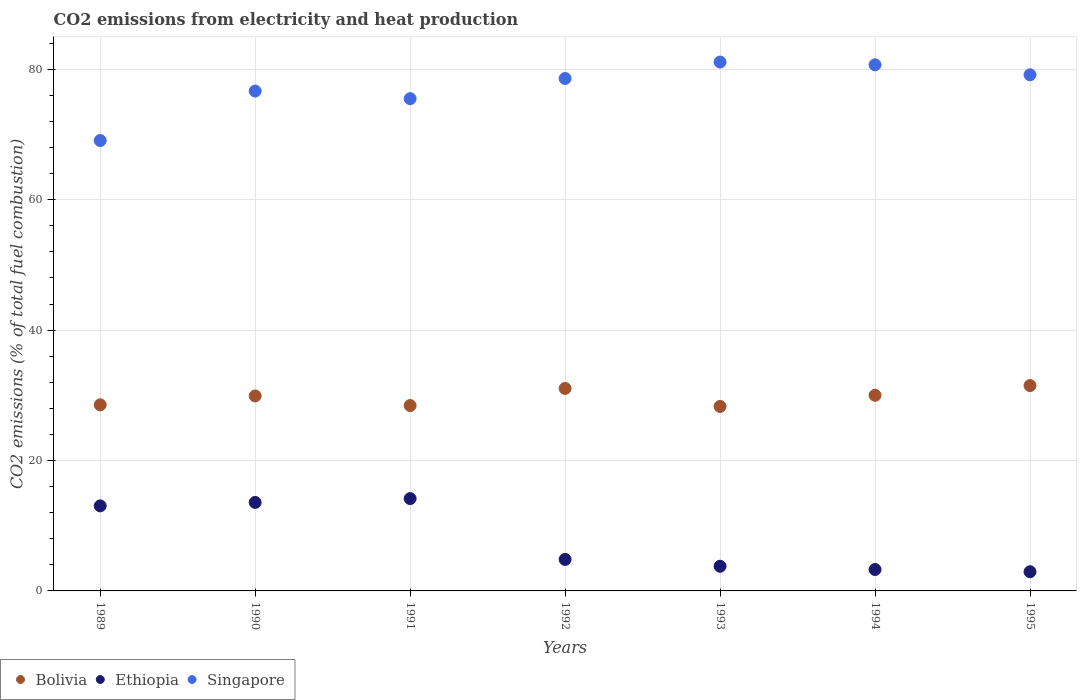How many different coloured dotlines are there?
Keep it short and to the point. 3. Is the number of dotlines equal to the number of legend labels?
Your answer should be very brief. Yes. What is the amount of CO2 emitted in Ethiopia in 1995?
Your answer should be very brief. 2.94. Across all years, what is the maximum amount of CO2 emitted in Ethiopia?
Your answer should be compact. 14.16. Across all years, what is the minimum amount of CO2 emitted in Bolivia?
Your response must be concise. 28.29. In which year was the amount of CO2 emitted in Singapore maximum?
Make the answer very short. 1993. In which year was the amount of CO2 emitted in Ethiopia minimum?
Give a very brief answer. 1995. What is the total amount of CO2 emitted in Bolivia in the graph?
Give a very brief answer. 207.72. What is the difference between the amount of CO2 emitted in Ethiopia in 1990 and that in 1993?
Provide a short and direct response. 9.79. What is the difference between the amount of CO2 emitted in Ethiopia in 1993 and the amount of CO2 emitted in Bolivia in 1992?
Provide a succinct answer. -27.27. What is the average amount of CO2 emitted in Singapore per year?
Offer a terse response. 77.25. In the year 1989, what is the difference between the amount of CO2 emitted in Bolivia and amount of CO2 emitted in Singapore?
Make the answer very short. -40.53. In how many years, is the amount of CO2 emitted in Bolivia greater than 52 %?
Offer a very short reply. 0. What is the ratio of the amount of CO2 emitted in Ethiopia in 1993 to that in 1995?
Offer a very short reply. 1.29. Is the difference between the amount of CO2 emitted in Bolivia in 1992 and 1993 greater than the difference between the amount of CO2 emitted in Singapore in 1992 and 1993?
Ensure brevity in your answer.  Yes. What is the difference between the highest and the second highest amount of CO2 emitted in Ethiopia?
Ensure brevity in your answer.  0.58. What is the difference between the highest and the lowest amount of CO2 emitted in Singapore?
Offer a terse response. 12.03. Is it the case that in every year, the sum of the amount of CO2 emitted in Ethiopia and amount of CO2 emitted in Singapore  is greater than the amount of CO2 emitted in Bolivia?
Offer a terse response. Yes. Does the amount of CO2 emitted in Ethiopia monotonically increase over the years?
Provide a succinct answer. No. Is the amount of CO2 emitted in Bolivia strictly greater than the amount of CO2 emitted in Singapore over the years?
Keep it short and to the point. No. Is the amount of CO2 emitted in Ethiopia strictly less than the amount of CO2 emitted in Bolivia over the years?
Provide a short and direct response. Yes. How many years are there in the graph?
Keep it short and to the point. 7. Does the graph contain grids?
Provide a succinct answer. Yes. How are the legend labels stacked?
Make the answer very short. Horizontal. What is the title of the graph?
Provide a short and direct response. CO2 emissions from electricity and heat production. What is the label or title of the X-axis?
Offer a terse response. Years. What is the label or title of the Y-axis?
Offer a terse response. CO2 emissions (% of total fuel combustion). What is the CO2 emissions (% of total fuel combustion) in Bolivia in 1989?
Make the answer very short. 28.54. What is the CO2 emissions (% of total fuel combustion) of Ethiopia in 1989?
Offer a terse response. 13.04. What is the CO2 emissions (% of total fuel combustion) in Singapore in 1989?
Your answer should be very brief. 69.07. What is the CO2 emissions (% of total fuel combustion) of Bolivia in 1990?
Offer a very short reply. 29.9. What is the CO2 emissions (% of total fuel combustion) in Ethiopia in 1990?
Your answer should be very brief. 13.57. What is the CO2 emissions (% of total fuel combustion) in Singapore in 1990?
Offer a very short reply. 76.66. What is the CO2 emissions (% of total fuel combustion) of Bolivia in 1991?
Provide a succinct answer. 28.43. What is the CO2 emissions (% of total fuel combustion) in Ethiopia in 1991?
Provide a succinct answer. 14.16. What is the CO2 emissions (% of total fuel combustion) of Singapore in 1991?
Keep it short and to the point. 75.5. What is the CO2 emissions (% of total fuel combustion) of Bolivia in 1992?
Offer a terse response. 31.05. What is the CO2 emissions (% of total fuel combustion) of Ethiopia in 1992?
Your answer should be very brief. 4.83. What is the CO2 emissions (% of total fuel combustion) in Singapore in 1992?
Keep it short and to the point. 78.59. What is the CO2 emissions (% of total fuel combustion) of Bolivia in 1993?
Give a very brief answer. 28.29. What is the CO2 emissions (% of total fuel combustion) of Ethiopia in 1993?
Offer a very short reply. 3.78. What is the CO2 emissions (% of total fuel combustion) in Singapore in 1993?
Ensure brevity in your answer.  81.11. What is the CO2 emissions (% of total fuel combustion) in Bolivia in 1994?
Your answer should be compact. 30. What is the CO2 emissions (% of total fuel combustion) in Ethiopia in 1994?
Give a very brief answer. 3.29. What is the CO2 emissions (% of total fuel combustion) in Singapore in 1994?
Your answer should be very brief. 80.69. What is the CO2 emissions (% of total fuel combustion) in Bolivia in 1995?
Your answer should be compact. 31.49. What is the CO2 emissions (% of total fuel combustion) in Ethiopia in 1995?
Provide a short and direct response. 2.94. What is the CO2 emissions (% of total fuel combustion) in Singapore in 1995?
Provide a short and direct response. 79.16. Across all years, what is the maximum CO2 emissions (% of total fuel combustion) of Bolivia?
Offer a terse response. 31.49. Across all years, what is the maximum CO2 emissions (% of total fuel combustion) in Ethiopia?
Provide a short and direct response. 14.16. Across all years, what is the maximum CO2 emissions (% of total fuel combustion) of Singapore?
Your response must be concise. 81.11. Across all years, what is the minimum CO2 emissions (% of total fuel combustion) of Bolivia?
Ensure brevity in your answer.  28.29. Across all years, what is the minimum CO2 emissions (% of total fuel combustion) of Ethiopia?
Your answer should be very brief. 2.94. Across all years, what is the minimum CO2 emissions (% of total fuel combustion) of Singapore?
Offer a terse response. 69.07. What is the total CO2 emissions (% of total fuel combustion) of Bolivia in the graph?
Your response must be concise. 207.72. What is the total CO2 emissions (% of total fuel combustion) in Ethiopia in the graph?
Keep it short and to the point. 55.62. What is the total CO2 emissions (% of total fuel combustion) in Singapore in the graph?
Ensure brevity in your answer.  540.77. What is the difference between the CO2 emissions (% of total fuel combustion) of Bolivia in 1989 and that in 1990?
Provide a short and direct response. -1.36. What is the difference between the CO2 emissions (% of total fuel combustion) of Ethiopia in 1989 and that in 1990?
Offer a very short reply. -0.53. What is the difference between the CO2 emissions (% of total fuel combustion) in Singapore in 1989 and that in 1990?
Ensure brevity in your answer.  -7.59. What is the difference between the CO2 emissions (% of total fuel combustion) of Bolivia in 1989 and that in 1991?
Provide a succinct answer. 0.11. What is the difference between the CO2 emissions (% of total fuel combustion) in Ethiopia in 1989 and that in 1991?
Your answer should be very brief. -1.12. What is the difference between the CO2 emissions (% of total fuel combustion) in Singapore in 1989 and that in 1991?
Keep it short and to the point. -6.42. What is the difference between the CO2 emissions (% of total fuel combustion) in Bolivia in 1989 and that in 1992?
Offer a terse response. -2.51. What is the difference between the CO2 emissions (% of total fuel combustion) of Ethiopia in 1989 and that in 1992?
Your response must be concise. 8.22. What is the difference between the CO2 emissions (% of total fuel combustion) in Singapore in 1989 and that in 1992?
Provide a succinct answer. -9.51. What is the difference between the CO2 emissions (% of total fuel combustion) of Bolivia in 1989 and that in 1993?
Offer a very short reply. 0.25. What is the difference between the CO2 emissions (% of total fuel combustion) in Ethiopia in 1989 and that in 1993?
Keep it short and to the point. 9.26. What is the difference between the CO2 emissions (% of total fuel combustion) of Singapore in 1989 and that in 1993?
Provide a succinct answer. -12.03. What is the difference between the CO2 emissions (% of total fuel combustion) of Bolivia in 1989 and that in 1994?
Give a very brief answer. -1.46. What is the difference between the CO2 emissions (% of total fuel combustion) of Ethiopia in 1989 and that in 1994?
Provide a succinct answer. 9.76. What is the difference between the CO2 emissions (% of total fuel combustion) in Singapore in 1989 and that in 1994?
Your answer should be compact. -11.61. What is the difference between the CO2 emissions (% of total fuel combustion) of Bolivia in 1989 and that in 1995?
Offer a terse response. -2.95. What is the difference between the CO2 emissions (% of total fuel combustion) of Ethiopia in 1989 and that in 1995?
Give a very brief answer. 10.1. What is the difference between the CO2 emissions (% of total fuel combustion) of Singapore in 1989 and that in 1995?
Make the answer very short. -10.08. What is the difference between the CO2 emissions (% of total fuel combustion) in Bolivia in 1990 and that in 1991?
Give a very brief answer. 1.47. What is the difference between the CO2 emissions (% of total fuel combustion) of Ethiopia in 1990 and that in 1991?
Your answer should be very brief. -0.58. What is the difference between the CO2 emissions (% of total fuel combustion) in Singapore in 1990 and that in 1991?
Give a very brief answer. 1.17. What is the difference between the CO2 emissions (% of total fuel combustion) in Bolivia in 1990 and that in 1992?
Offer a terse response. -1.15. What is the difference between the CO2 emissions (% of total fuel combustion) in Ethiopia in 1990 and that in 1992?
Your response must be concise. 8.75. What is the difference between the CO2 emissions (% of total fuel combustion) of Singapore in 1990 and that in 1992?
Ensure brevity in your answer.  -1.93. What is the difference between the CO2 emissions (% of total fuel combustion) of Bolivia in 1990 and that in 1993?
Your answer should be very brief. 1.61. What is the difference between the CO2 emissions (% of total fuel combustion) in Ethiopia in 1990 and that in 1993?
Keep it short and to the point. 9.79. What is the difference between the CO2 emissions (% of total fuel combustion) in Singapore in 1990 and that in 1993?
Keep it short and to the point. -4.45. What is the difference between the CO2 emissions (% of total fuel combustion) of Bolivia in 1990 and that in 1994?
Provide a short and direct response. -0.1. What is the difference between the CO2 emissions (% of total fuel combustion) of Ethiopia in 1990 and that in 1994?
Make the answer very short. 10.29. What is the difference between the CO2 emissions (% of total fuel combustion) in Singapore in 1990 and that in 1994?
Your answer should be very brief. -4.03. What is the difference between the CO2 emissions (% of total fuel combustion) in Bolivia in 1990 and that in 1995?
Ensure brevity in your answer.  -1.59. What is the difference between the CO2 emissions (% of total fuel combustion) in Ethiopia in 1990 and that in 1995?
Your answer should be compact. 10.63. What is the difference between the CO2 emissions (% of total fuel combustion) in Singapore in 1990 and that in 1995?
Your answer should be compact. -2.49. What is the difference between the CO2 emissions (% of total fuel combustion) in Bolivia in 1991 and that in 1992?
Provide a succinct answer. -2.62. What is the difference between the CO2 emissions (% of total fuel combustion) in Ethiopia in 1991 and that in 1992?
Keep it short and to the point. 9.33. What is the difference between the CO2 emissions (% of total fuel combustion) in Singapore in 1991 and that in 1992?
Provide a short and direct response. -3.09. What is the difference between the CO2 emissions (% of total fuel combustion) in Bolivia in 1991 and that in 1993?
Ensure brevity in your answer.  0.14. What is the difference between the CO2 emissions (% of total fuel combustion) in Ethiopia in 1991 and that in 1993?
Offer a terse response. 10.38. What is the difference between the CO2 emissions (% of total fuel combustion) in Singapore in 1991 and that in 1993?
Your answer should be very brief. -5.61. What is the difference between the CO2 emissions (% of total fuel combustion) in Bolivia in 1991 and that in 1994?
Your response must be concise. -1.57. What is the difference between the CO2 emissions (% of total fuel combustion) in Ethiopia in 1991 and that in 1994?
Your answer should be very brief. 10.87. What is the difference between the CO2 emissions (% of total fuel combustion) of Singapore in 1991 and that in 1994?
Provide a succinct answer. -5.19. What is the difference between the CO2 emissions (% of total fuel combustion) of Bolivia in 1991 and that in 1995?
Make the answer very short. -3.06. What is the difference between the CO2 emissions (% of total fuel combustion) of Ethiopia in 1991 and that in 1995?
Offer a terse response. 11.22. What is the difference between the CO2 emissions (% of total fuel combustion) in Singapore in 1991 and that in 1995?
Offer a terse response. -3.66. What is the difference between the CO2 emissions (% of total fuel combustion) in Bolivia in 1992 and that in 1993?
Offer a very short reply. 2.76. What is the difference between the CO2 emissions (% of total fuel combustion) of Ethiopia in 1992 and that in 1993?
Ensure brevity in your answer.  1.04. What is the difference between the CO2 emissions (% of total fuel combustion) in Singapore in 1992 and that in 1993?
Keep it short and to the point. -2.52. What is the difference between the CO2 emissions (% of total fuel combustion) in Bolivia in 1992 and that in 1994?
Offer a terse response. 1.05. What is the difference between the CO2 emissions (% of total fuel combustion) of Ethiopia in 1992 and that in 1994?
Your answer should be compact. 1.54. What is the difference between the CO2 emissions (% of total fuel combustion) of Singapore in 1992 and that in 1994?
Make the answer very short. -2.1. What is the difference between the CO2 emissions (% of total fuel combustion) in Bolivia in 1992 and that in 1995?
Give a very brief answer. -0.44. What is the difference between the CO2 emissions (% of total fuel combustion) of Ethiopia in 1992 and that in 1995?
Keep it short and to the point. 1.89. What is the difference between the CO2 emissions (% of total fuel combustion) in Singapore in 1992 and that in 1995?
Offer a very short reply. -0.57. What is the difference between the CO2 emissions (% of total fuel combustion) in Bolivia in 1993 and that in 1994?
Your answer should be compact. -1.71. What is the difference between the CO2 emissions (% of total fuel combustion) of Ethiopia in 1993 and that in 1994?
Give a very brief answer. 0.5. What is the difference between the CO2 emissions (% of total fuel combustion) of Singapore in 1993 and that in 1994?
Keep it short and to the point. 0.42. What is the difference between the CO2 emissions (% of total fuel combustion) in Bolivia in 1993 and that in 1995?
Your answer should be compact. -3.2. What is the difference between the CO2 emissions (% of total fuel combustion) of Ethiopia in 1993 and that in 1995?
Your answer should be compact. 0.84. What is the difference between the CO2 emissions (% of total fuel combustion) of Singapore in 1993 and that in 1995?
Give a very brief answer. 1.95. What is the difference between the CO2 emissions (% of total fuel combustion) in Bolivia in 1994 and that in 1995?
Keep it short and to the point. -1.49. What is the difference between the CO2 emissions (% of total fuel combustion) of Ethiopia in 1994 and that in 1995?
Offer a very short reply. 0.35. What is the difference between the CO2 emissions (% of total fuel combustion) in Singapore in 1994 and that in 1995?
Your answer should be compact. 1.53. What is the difference between the CO2 emissions (% of total fuel combustion) of Bolivia in 1989 and the CO2 emissions (% of total fuel combustion) of Ethiopia in 1990?
Ensure brevity in your answer.  14.97. What is the difference between the CO2 emissions (% of total fuel combustion) of Bolivia in 1989 and the CO2 emissions (% of total fuel combustion) of Singapore in 1990?
Keep it short and to the point. -48.12. What is the difference between the CO2 emissions (% of total fuel combustion) of Ethiopia in 1989 and the CO2 emissions (% of total fuel combustion) of Singapore in 1990?
Give a very brief answer. -63.62. What is the difference between the CO2 emissions (% of total fuel combustion) in Bolivia in 1989 and the CO2 emissions (% of total fuel combustion) in Ethiopia in 1991?
Offer a terse response. 14.38. What is the difference between the CO2 emissions (% of total fuel combustion) of Bolivia in 1989 and the CO2 emissions (% of total fuel combustion) of Singapore in 1991?
Provide a succinct answer. -46.95. What is the difference between the CO2 emissions (% of total fuel combustion) in Ethiopia in 1989 and the CO2 emissions (% of total fuel combustion) in Singapore in 1991?
Keep it short and to the point. -62.45. What is the difference between the CO2 emissions (% of total fuel combustion) of Bolivia in 1989 and the CO2 emissions (% of total fuel combustion) of Ethiopia in 1992?
Give a very brief answer. 23.71. What is the difference between the CO2 emissions (% of total fuel combustion) of Bolivia in 1989 and the CO2 emissions (% of total fuel combustion) of Singapore in 1992?
Offer a very short reply. -50.05. What is the difference between the CO2 emissions (% of total fuel combustion) in Ethiopia in 1989 and the CO2 emissions (% of total fuel combustion) in Singapore in 1992?
Your answer should be very brief. -65.54. What is the difference between the CO2 emissions (% of total fuel combustion) in Bolivia in 1989 and the CO2 emissions (% of total fuel combustion) in Ethiopia in 1993?
Make the answer very short. 24.76. What is the difference between the CO2 emissions (% of total fuel combustion) in Bolivia in 1989 and the CO2 emissions (% of total fuel combustion) in Singapore in 1993?
Your answer should be compact. -52.57. What is the difference between the CO2 emissions (% of total fuel combustion) in Ethiopia in 1989 and the CO2 emissions (% of total fuel combustion) in Singapore in 1993?
Give a very brief answer. -68.06. What is the difference between the CO2 emissions (% of total fuel combustion) of Bolivia in 1989 and the CO2 emissions (% of total fuel combustion) of Ethiopia in 1994?
Provide a short and direct response. 25.25. What is the difference between the CO2 emissions (% of total fuel combustion) in Bolivia in 1989 and the CO2 emissions (% of total fuel combustion) in Singapore in 1994?
Provide a short and direct response. -52.15. What is the difference between the CO2 emissions (% of total fuel combustion) in Ethiopia in 1989 and the CO2 emissions (% of total fuel combustion) in Singapore in 1994?
Your answer should be compact. -67.64. What is the difference between the CO2 emissions (% of total fuel combustion) in Bolivia in 1989 and the CO2 emissions (% of total fuel combustion) in Ethiopia in 1995?
Your response must be concise. 25.6. What is the difference between the CO2 emissions (% of total fuel combustion) of Bolivia in 1989 and the CO2 emissions (% of total fuel combustion) of Singapore in 1995?
Make the answer very short. -50.61. What is the difference between the CO2 emissions (% of total fuel combustion) of Ethiopia in 1989 and the CO2 emissions (% of total fuel combustion) of Singapore in 1995?
Offer a very short reply. -66.11. What is the difference between the CO2 emissions (% of total fuel combustion) of Bolivia in 1990 and the CO2 emissions (% of total fuel combustion) of Ethiopia in 1991?
Provide a short and direct response. 15.74. What is the difference between the CO2 emissions (% of total fuel combustion) in Bolivia in 1990 and the CO2 emissions (% of total fuel combustion) in Singapore in 1991?
Keep it short and to the point. -45.59. What is the difference between the CO2 emissions (% of total fuel combustion) in Ethiopia in 1990 and the CO2 emissions (% of total fuel combustion) in Singapore in 1991?
Your answer should be very brief. -61.92. What is the difference between the CO2 emissions (% of total fuel combustion) in Bolivia in 1990 and the CO2 emissions (% of total fuel combustion) in Ethiopia in 1992?
Your response must be concise. 25.08. What is the difference between the CO2 emissions (% of total fuel combustion) in Bolivia in 1990 and the CO2 emissions (% of total fuel combustion) in Singapore in 1992?
Ensure brevity in your answer.  -48.68. What is the difference between the CO2 emissions (% of total fuel combustion) of Ethiopia in 1990 and the CO2 emissions (% of total fuel combustion) of Singapore in 1992?
Make the answer very short. -65.01. What is the difference between the CO2 emissions (% of total fuel combustion) of Bolivia in 1990 and the CO2 emissions (% of total fuel combustion) of Ethiopia in 1993?
Provide a short and direct response. 26.12. What is the difference between the CO2 emissions (% of total fuel combustion) of Bolivia in 1990 and the CO2 emissions (% of total fuel combustion) of Singapore in 1993?
Offer a terse response. -51.2. What is the difference between the CO2 emissions (% of total fuel combustion) in Ethiopia in 1990 and the CO2 emissions (% of total fuel combustion) in Singapore in 1993?
Give a very brief answer. -67.53. What is the difference between the CO2 emissions (% of total fuel combustion) of Bolivia in 1990 and the CO2 emissions (% of total fuel combustion) of Ethiopia in 1994?
Keep it short and to the point. 26.62. What is the difference between the CO2 emissions (% of total fuel combustion) of Bolivia in 1990 and the CO2 emissions (% of total fuel combustion) of Singapore in 1994?
Provide a short and direct response. -50.78. What is the difference between the CO2 emissions (% of total fuel combustion) of Ethiopia in 1990 and the CO2 emissions (% of total fuel combustion) of Singapore in 1994?
Provide a short and direct response. -67.11. What is the difference between the CO2 emissions (% of total fuel combustion) of Bolivia in 1990 and the CO2 emissions (% of total fuel combustion) of Ethiopia in 1995?
Keep it short and to the point. 26.96. What is the difference between the CO2 emissions (% of total fuel combustion) in Bolivia in 1990 and the CO2 emissions (% of total fuel combustion) in Singapore in 1995?
Ensure brevity in your answer.  -49.25. What is the difference between the CO2 emissions (% of total fuel combustion) of Ethiopia in 1990 and the CO2 emissions (% of total fuel combustion) of Singapore in 1995?
Keep it short and to the point. -65.58. What is the difference between the CO2 emissions (% of total fuel combustion) in Bolivia in 1991 and the CO2 emissions (% of total fuel combustion) in Ethiopia in 1992?
Your answer should be compact. 23.61. What is the difference between the CO2 emissions (% of total fuel combustion) in Bolivia in 1991 and the CO2 emissions (% of total fuel combustion) in Singapore in 1992?
Your answer should be compact. -50.15. What is the difference between the CO2 emissions (% of total fuel combustion) of Ethiopia in 1991 and the CO2 emissions (% of total fuel combustion) of Singapore in 1992?
Offer a terse response. -64.43. What is the difference between the CO2 emissions (% of total fuel combustion) of Bolivia in 1991 and the CO2 emissions (% of total fuel combustion) of Ethiopia in 1993?
Provide a succinct answer. 24.65. What is the difference between the CO2 emissions (% of total fuel combustion) in Bolivia in 1991 and the CO2 emissions (% of total fuel combustion) in Singapore in 1993?
Your response must be concise. -52.67. What is the difference between the CO2 emissions (% of total fuel combustion) of Ethiopia in 1991 and the CO2 emissions (% of total fuel combustion) of Singapore in 1993?
Your answer should be very brief. -66.95. What is the difference between the CO2 emissions (% of total fuel combustion) in Bolivia in 1991 and the CO2 emissions (% of total fuel combustion) in Ethiopia in 1994?
Give a very brief answer. 25.15. What is the difference between the CO2 emissions (% of total fuel combustion) of Bolivia in 1991 and the CO2 emissions (% of total fuel combustion) of Singapore in 1994?
Keep it short and to the point. -52.25. What is the difference between the CO2 emissions (% of total fuel combustion) of Ethiopia in 1991 and the CO2 emissions (% of total fuel combustion) of Singapore in 1994?
Keep it short and to the point. -66.53. What is the difference between the CO2 emissions (% of total fuel combustion) in Bolivia in 1991 and the CO2 emissions (% of total fuel combustion) in Ethiopia in 1995?
Make the answer very short. 25.49. What is the difference between the CO2 emissions (% of total fuel combustion) of Bolivia in 1991 and the CO2 emissions (% of total fuel combustion) of Singapore in 1995?
Provide a short and direct response. -50.72. What is the difference between the CO2 emissions (% of total fuel combustion) of Ethiopia in 1991 and the CO2 emissions (% of total fuel combustion) of Singapore in 1995?
Your answer should be very brief. -65. What is the difference between the CO2 emissions (% of total fuel combustion) of Bolivia in 1992 and the CO2 emissions (% of total fuel combustion) of Ethiopia in 1993?
Make the answer very short. 27.27. What is the difference between the CO2 emissions (% of total fuel combustion) in Bolivia in 1992 and the CO2 emissions (% of total fuel combustion) in Singapore in 1993?
Give a very brief answer. -50.05. What is the difference between the CO2 emissions (% of total fuel combustion) in Ethiopia in 1992 and the CO2 emissions (% of total fuel combustion) in Singapore in 1993?
Provide a succinct answer. -76.28. What is the difference between the CO2 emissions (% of total fuel combustion) of Bolivia in 1992 and the CO2 emissions (% of total fuel combustion) of Ethiopia in 1994?
Ensure brevity in your answer.  27.77. What is the difference between the CO2 emissions (% of total fuel combustion) in Bolivia in 1992 and the CO2 emissions (% of total fuel combustion) in Singapore in 1994?
Your answer should be very brief. -49.63. What is the difference between the CO2 emissions (% of total fuel combustion) of Ethiopia in 1992 and the CO2 emissions (% of total fuel combustion) of Singapore in 1994?
Your answer should be very brief. -75.86. What is the difference between the CO2 emissions (% of total fuel combustion) in Bolivia in 1992 and the CO2 emissions (% of total fuel combustion) in Ethiopia in 1995?
Offer a terse response. 28.11. What is the difference between the CO2 emissions (% of total fuel combustion) of Bolivia in 1992 and the CO2 emissions (% of total fuel combustion) of Singapore in 1995?
Your answer should be compact. -48.1. What is the difference between the CO2 emissions (% of total fuel combustion) of Ethiopia in 1992 and the CO2 emissions (% of total fuel combustion) of Singapore in 1995?
Keep it short and to the point. -74.33. What is the difference between the CO2 emissions (% of total fuel combustion) of Bolivia in 1993 and the CO2 emissions (% of total fuel combustion) of Ethiopia in 1994?
Ensure brevity in your answer.  25.01. What is the difference between the CO2 emissions (% of total fuel combustion) in Bolivia in 1993 and the CO2 emissions (% of total fuel combustion) in Singapore in 1994?
Provide a short and direct response. -52.4. What is the difference between the CO2 emissions (% of total fuel combustion) in Ethiopia in 1993 and the CO2 emissions (% of total fuel combustion) in Singapore in 1994?
Offer a terse response. -76.9. What is the difference between the CO2 emissions (% of total fuel combustion) of Bolivia in 1993 and the CO2 emissions (% of total fuel combustion) of Ethiopia in 1995?
Ensure brevity in your answer.  25.35. What is the difference between the CO2 emissions (% of total fuel combustion) in Bolivia in 1993 and the CO2 emissions (% of total fuel combustion) in Singapore in 1995?
Your answer should be very brief. -50.86. What is the difference between the CO2 emissions (% of total fuel combustion) of Ethiopia in 1993 and the CO2 emissions (% of total fuel combustion) of Singapore in 1995?
Offer a terse response. -75.37. What is the difference between the CO2 emissions (% of total fuel combustion) in Bolivia in 1994 and the CO2 emissions (% of total fuel combustion) in Ethiopia in 1995?
Your answer should be very brief. 27.06. What is the difference between the CO2 emissions (% of total fuel combustion) in Bolivia in 1994 and the CO2 emissions (% of total fuel combustion) in Singapore in 1995?
Give a very brief answer. -49.16. What is the difference between the CO2 emissions (% of total fuel combustion) of Ethiopia in 1994 and the CO2 emissions (% of total fuel combustion) of Singapore in 1995?
Provide a short and direct response. -75.87. What is the average CO2 emissions (% of total fuel combustion) in Bolivia per year?
Ensure brevity in your answer.  29.67. What is the average CO2 emissions (% of total fuel combustion) of Ethiopia per year?
Give a very brief answer. 7.95. What is the average CO2 emissions (% of total fuel combustion) in Singapore per year?
Offer a terse response. 77.25. In the year 1989, what is the difference between the CO2 emissions (% of total fuel combustion) of Bolivia and CO2 emissions (% of total fuel combustion) of Ethiopia?
Your answer should be very brief. 15.5. In the year 1989, what is the difference between the CO2 emissions (% of total fuel combustion) in Bolivia and CO2 emissions (% of total fuel combustion) in Singapore?
Your response must be concise. -40.53. In the year 1989, what is the difference between the CO2 emissions (% of total fuel combustion) in Ethiopia and CO2 emissions (% of total fuel combustion) in Singapore?
Ensure brevity in your answer.  -56.03. In the year 1990, what is the difference between the CO2 emissions (% of total fuel combustion) in Bolivia and CO2 emissions (% of total fuel combustion) in Ethiopia?
Make the answer very short. 16.33. In the year 1990, what is the difference between the CO2 emissions (% of total fuel combustion) in Bolivia and CO2 emissions (% of total fuel combustion) in Singapore?
Make the answer very short. -46.76. In the year 1990, what is the difference between the CO2 emissions (% of total fuel combustion) of Ethiopia and CO2 emissions (% of total fuel combustion) of Singapore?
Your answer should be compact. -63.09. In the year 1991, what is the difference between the CO2 emissions (% of total fuel combustion) of Bolivia and CO2 emissions (% of total fuel combustion) of Ethiopia?
Offer a very short reply. 14.27. In the year 1991, what is the difference between the CO2 emissions (% of total fuel combustion) in Bolivia and CO2 emissions (% of total fuel combustion) in Singapore?
Ensure brevity in your answer.  -47.06. In the year 1991, what is the difference between the CO2 emissions (% of total fuel combustion) in Ethiopia and CO2 emissions (% of total fuel combustion) in Singapore?
Ensure brevity in your answer.  -61.34. In the year 1992, what is the difference between the CO2 emissions (% of total fuel combustion) in Bolivia and CO2 emissions (% of total fuel combustion) in Ethiopia?
Make the answer very short. 26.23. In the year 1992, what is the difference between the CO2 emissions (% of total fuel combustion) in Bolivia and CO2 emissions (% of total fuel combustion) in Singapore?
Provide a short and direct response. -47.53. In the year 1992, what is the difference between the CO2 emissions (% of total fuel combustion) in Ethiopia and CO2 emissions (% of total fuel combustion) in Singapore?
Make the answer very short. -73.76. In the year 1993, what is the difference between the CO2 emissions (% of total fuel combustion) of Bolivia and CO2 emissions (% of total fuel combustion) of Ethiopia?
Ensure brevity in your answer.  24.51. In the year 1993, what is the difference between the CO2 emissions (% of total fuel combustion) of Bolivia and CO2 emissions (% of total fuel combustion) of Singapore?
Provide a succinct answer. -52.82. In the year 1993, what is the difference between the CO2 emissions (% of total fuel combustion) in Ethiopia and CO2 emissions (% of total fuel combustion) in Singapore?
Your answer should be very brief. -77.32. In the year 1994, what is the difference between the CO2 emissions (% of total fuel combustion) of Bolivia and CO2 emissions (% of total fuel combustion) of Ethiopia?
Your answer should be very brief. 26.71. In the year 1994, what is the difference between the CO2 emissions (% of total fuel combustion) in Bolivia and CO2 emissions (% of total fuel combustion) in Singapore?
Your answer should be very brief. -50.69. In the year 1994, what is the difference between the CO2 emissions (% of total fuel combustion) in Ethiopia and CO2 emissions (% of total fuel combustion) in Singapore?
Make the answer very short. -77.4. In the year 1995, what is the difference between the CO2 emissions (% of total fuel combustion) of Bolivia and CO2 emissions (% of total fuel combustion) of Ethiopia?
Offer a very short reply. 28.55. In the year 1995, what is the difference between the CO2 emissions (% of total fuel combustion) in Bolivia and CO2 emissions (% of total fuel combustion) in Singapore?
Provide a succinct answer. -47.66. In the year 1995, what is the difference between the CO2 emissions (% of total fuel combustion) in Ethiopia and CO2 emissions (% of total fuel combustion) in Singapore?
Your answer should be very brief. -76.21. What is the ratio of the CO2 emissions (% of total fuel combustion) of Bolivia in 1989 to that in 1990?
Your answer should be compact. 0.95. What is the ratio of the CO2 emissions (% of total fuel combustion) in Ethiopia in 1989 to that in 1990?
Give a very brief answer. 0.96. What is the ratio of the CO2 emissions (% of total fuel combustion) of Singapore in 1989 to that in 1990?
Offer a very short reply. 0.9. What is the ratio of the CO2 emissions (% of total fuel combustion) of Bolivia in 1989 to that in 1991?
Keep it short and to the point. 1. What is the ratio of the CO2 emissions (% of total fuel combustion) of Ethiopia in 1989 to that in 1991?
Provide a short and direct response. 0.92. What is the ratio of the CO2 emissions (% of total fuel combustion) in Singapore in 1989 to that in 1991?
Give a very brief answer. 0.91. What is the ratio of the CO2 emissions (% of total fuel combustion) in Bolivia in 1989 to that in 1992?
Your answer should be very brief. 0.92. What is the ratio of the CO2 emissions (% of total fuel combustion) in Ethiopia in 1989 to that in 1992?
Offer a terse response. 2.7. What is the ratio of the CO2 emissions (% of total fuel combustion) of Singapore in 1989 to that in 1992?
Your answer should be compact. 0.88. What is the ratio of the CO2 emissions (% of total fuel combustion) in Bolivia in 1989 to that in 1993?
Your answer should be compact. 1.01. What is the ratio of the CO2 emissions (% of total fuel combustion) of Ethiopia in 1989 to that in 1993?
Provide a succinct answer. 3.45. What is the ratio of the CO2 emissions (% of total fuel combustion) in Singapore in 1989 to that in 1993?
Offer a terse response. 0.85. What is the ratio of the CO2 emissions (% of total fuel combustion) of Bolivia in 1989 to that in 1994?
Provide a short and direct response. 0.95. What is the ratio of the CO2 emissions (% of total fuel combustion) in Ethiopia in 1989 to that in 1994?
Keep it short and to the point. 3.97. What is the ratio of the CO2 emissions (% of total fuel combustion) in Singapore in 1989 to that in 1994?
Offer a terse response. 0.86. What is the ratio of the CO2 emissions (% of total fuel combustion) in Bolivia in 1989 to that in 1995?
Provide a short and direct response. 0.91. What is the ratio of the CO2 emissions (% of total fuel combustion) of Ethiopia in 1989 to that in 1995?
Offer a terse response. 4.43. What is the ratio of the CO2 emissions (% of total fuel combustion) of Singapore in 1989 to that in 1995?
Provide a short and direct response. 0.87. What is the ratio of the CO2 emissions (% of total fuel combustion) in Bolivia in 1990 to that in 1991?
Your answer should be very brief. 1.05. What is the ratio of the CO2 emissions (% of total fuel combustion) in Ethiopia in 1990 to that in 1991?
Give a very brief answer. 0.96. What is the ratio of the CO2 emissions (% of total fuel combustion) of Singapore in 1990 to that in 1991?
Keep it short and to the point. 1.02. What is the ratio of the CO2 emissions (% of total fuel combustion) in Bolivia in 1990 to that in 1992?
Offer a terse response. 0.96. What is the ratio of the CO2 emissions (% of total fuel combustion) of Ethiopia in 1990 to that in 1992?
Provide a succinct answer. 2.81. What is the ratio of the CO2 emissions (% of total fuel combustion) of Singapore in 1990 to that in 1992?
Provide a short and direct response. 0.98. What is the ratio of the CO2 emissions (% of total fuel combustion) in Bolivia in 1990 to that in 1993?
Offer a terse response. 1.06. What is the ratio of the CO2 emissions (% of total fuel combustion) in Ethiopia in 1990 to that in 1993?
Your answer should be very brief. 3.59. What is the ratio of the CO2 emissions (% of total fuel combustion) in Singapore in 1990 to that in 1993?
Your answer should be very brief. 0.95. What is the ratio of the CO2 emissions (% of total fuel combustion) in Bolivia in 1990 to that in 1994?
Provide a short and direct response. 1. What is the ratio of the CO2 emissions (% of total fuel combustion) in Ethiopia in 1990 to that in 1994?
Offer a terse response. 4.13. What is the ratio of the CO2 emissions (% of total fuel combustion) of Singapore in 1990 to that in 1994?
Provide a short and direct response. 0.95. What is the ratio of the CO2 emissions (% of total fuel combustion) of Bolivia in 1990 to that in 1995?
Provide a short and direct response. 0.95. What is the ratio of the CO2 emissions (% of total fuel combustion) in Ethiopia in 1990 to that in 1995?
Provide a short and direct response. 4.62. What is the ratio of the CO2 emissions (% of total fuel combustion) of Singapore in 1990 to that in 1995?
Your answer should be compact. 0.97. What is the ratio of the CO2 emissions (% of total fuel combustion) of Bolivia in 1991 to that in 1992?
Keep it short and to the point. 0.92. What is the ratio of the CO2 emissions (% of total fuel combustion) of Ethiopia in 1991 to that in 1992?
Offer a terse response. 2.93. What is the ratio of the CO2 emissions (% of total fuel combustion) of Singapore in 1991 to that in 1992?
Ensure brevity in your answer.  0.96. What is the ratio of the CO2 emissions (% of total fuel combustion) in Ethiopia in 1991 to that in 1993?
Provide a short and direct response. 3.74. What is the ratio of the CO2 emissions (% of total fuel combustion) of Singapore in 1991 to that in 1993?
Your answer should be compact. 0.93. What is the ratio of the CO2 emissions (% of total fuel combustion) of Bolivia in 1991 to that in 1994?
Ensure brevity in your answer.  0.95. What is the ratio of the CO2 emissions (% of total fuel combustion) of Ethiopia in 1991 to that in 1994?
Give a very brief answer. 4.31. What is the ratio of the CO2 emissions (% of total fuel combustion) in Singapore in 1991 to that in 1994?
Your answer should be compact. 0.94. What is the ratio of the CO2 emissions (% of total fuel combustion) in Bolivia in 1991 to that in 1995?
Your response must be concise. 0.9. What is the ratio of the CO2 emissions (% of total fuel combustion) in Ethiopia in 1991 to that in 1995?
Your answer should be compact. 4.81. What is the ratio of the CO2 emissions (% of total fuel combustion) of Singapore in 1991 to that in 1995?
Offer a terse response. 0.95. What is the ratio of the CO2 emissions (% of total fuel combustion) in Bolivia in 1992 to that in 1993?
Your answer should be compact. 1.1. What is the ratio of the CO2 emissions (% of total fuel combustion) of Ethiopia in 1992 to that in 1993?
Your answer should be compact. 1.28. What is the ratio of the CO2 emissions (% of total fuel combustion) of Singapore in 1992 to that in 1993?
Your answer should be compact. 0.97. What is the ratio of the CO2 emissions (% of total fuel combustion) in Bolivia in 1992 to that in 1994?
Your answer should be compact. 1.04. What is the ratio of the CO2 emissions (% of total fuel combustion) of Ethiopia in 1992 to that in 1994?
Provide a short and direct response. 1.47. What is the ratio of the CO2 emissions (% of total fuel combustion) of Singapore in 1992 to that in 1994?
Provide a short and direct response. 0.97. What is the ratio of the CO2 emissions (% of total fuel combustion) of Ethiopia in 1992 to that in 1995?
Your response must be concise. 1.64. What is the ratio of the CO2 emissions (% of total fuel combustion) in Bolivia in 1993 to that in 1994?
Give a very brief answer. 0.94. What is the ratio of the CO2 emissions (% of total fuel combustion) of Ethiopia in 1993 to that in 1994?
Provide a short and direct response. 1.15. What is the ratio of the CO2 emissions (% of total fuel combustion) of Singapore in 1993 to that in 1994?
Provide a succinct answer. 1.01. What is the ratio of the CO2 emissions (% of total fuel combustion) of Bolivia in 1993 to that in 1995?
Provide a short and direct response. 0.9. What is the ratio of the CO2 emissions (% of total fuel combustion) of Ethiopia in 1993 to that in 1995?
Make the answer very short. 1.29. What is the ratio of the CO2 emissions (% of total fuel combustion) of Singapore in 1993 to that in 1995?
Offer a very short reply. 1.02. What is the ratio of the CO2 emissions (% of total fuel combustion) in Bolivia in 1994 to that in 1995?
Give a very brief answer. 0.95. What is the ratio of the CO2 emissions (% of total fuel combustion) in Ethiopia in 1994 to that in 1995?
Give a very brief answer. 1.12. What is the ratio of the CO2 emissions (% of total fuel combustion) in Singapore in 1994 to that in 1995?
Give a very brief answer. 1.02. What is the difference between the highest and the second highest CO2 emissions (% of total fuel combustion) of Bolivia?
Provide a succinct answer. 0.44. What is the difference between the highest and the second highest CO2 emissions (% of total fuel combustion) in Ethiopia?
Provide a short and direct response. 0.58. What is the difference between the highest and the second highest CO2 emissions (% of total fuel combustion) of Singapore?
Make the answer very short. 0.42. What is the difference between the highest and the lowest CO2 emissions (% of total fuel combustion) of Bolivia?
Your answer should be compact. 3.2. What is the difference between the highest and the lowest CO2 emissions (% of total fuel combustion) in Ethiopia?
Provide a short and direct response. 11.22. What is the difference between the highest and the lowest CO2 emissions (% of total fuel combustion) of Singapore?
Provide a succinct answer. 12.03. 